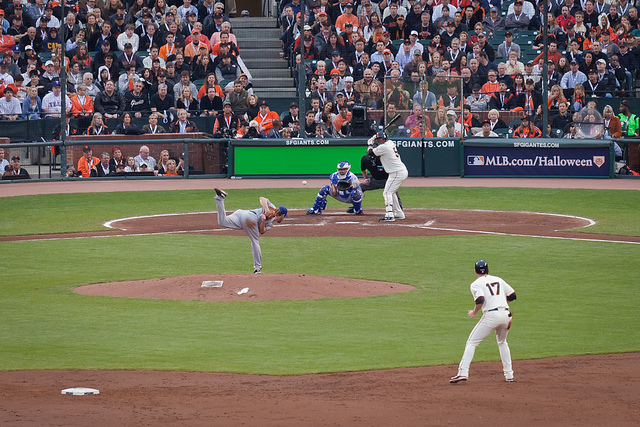Identify the text displayed in this image. MLB.com/hHalloween 17 